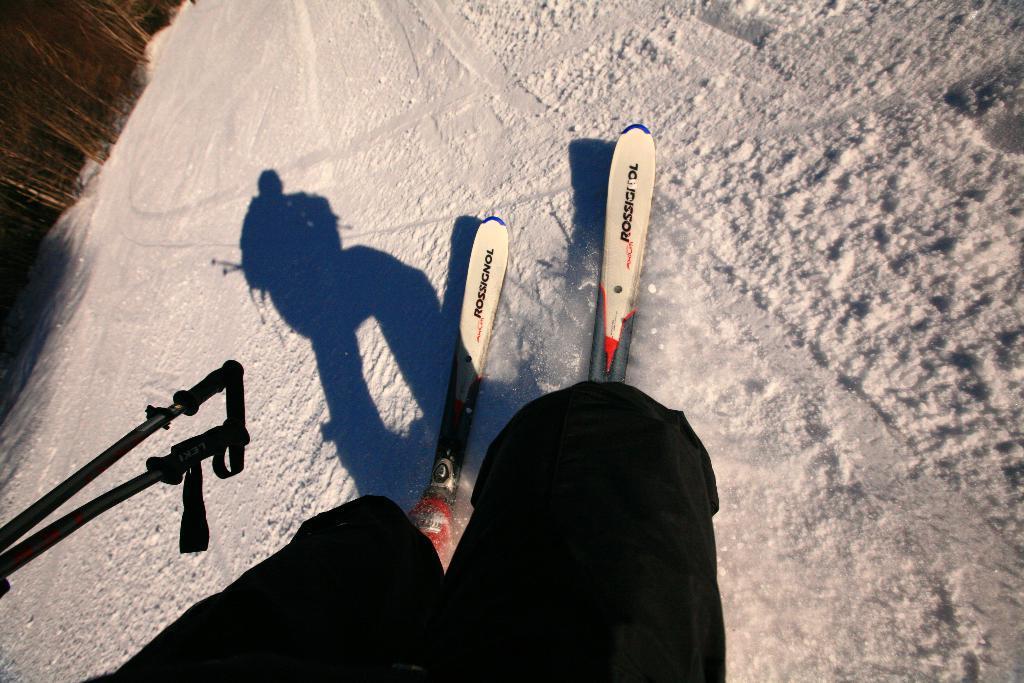Can you describe this image briefly? At the bottom of this image I can see a person's legs and also there are two skateboards and sticks. Here I can see the snow. In the top left-hand corner there are many trees. 